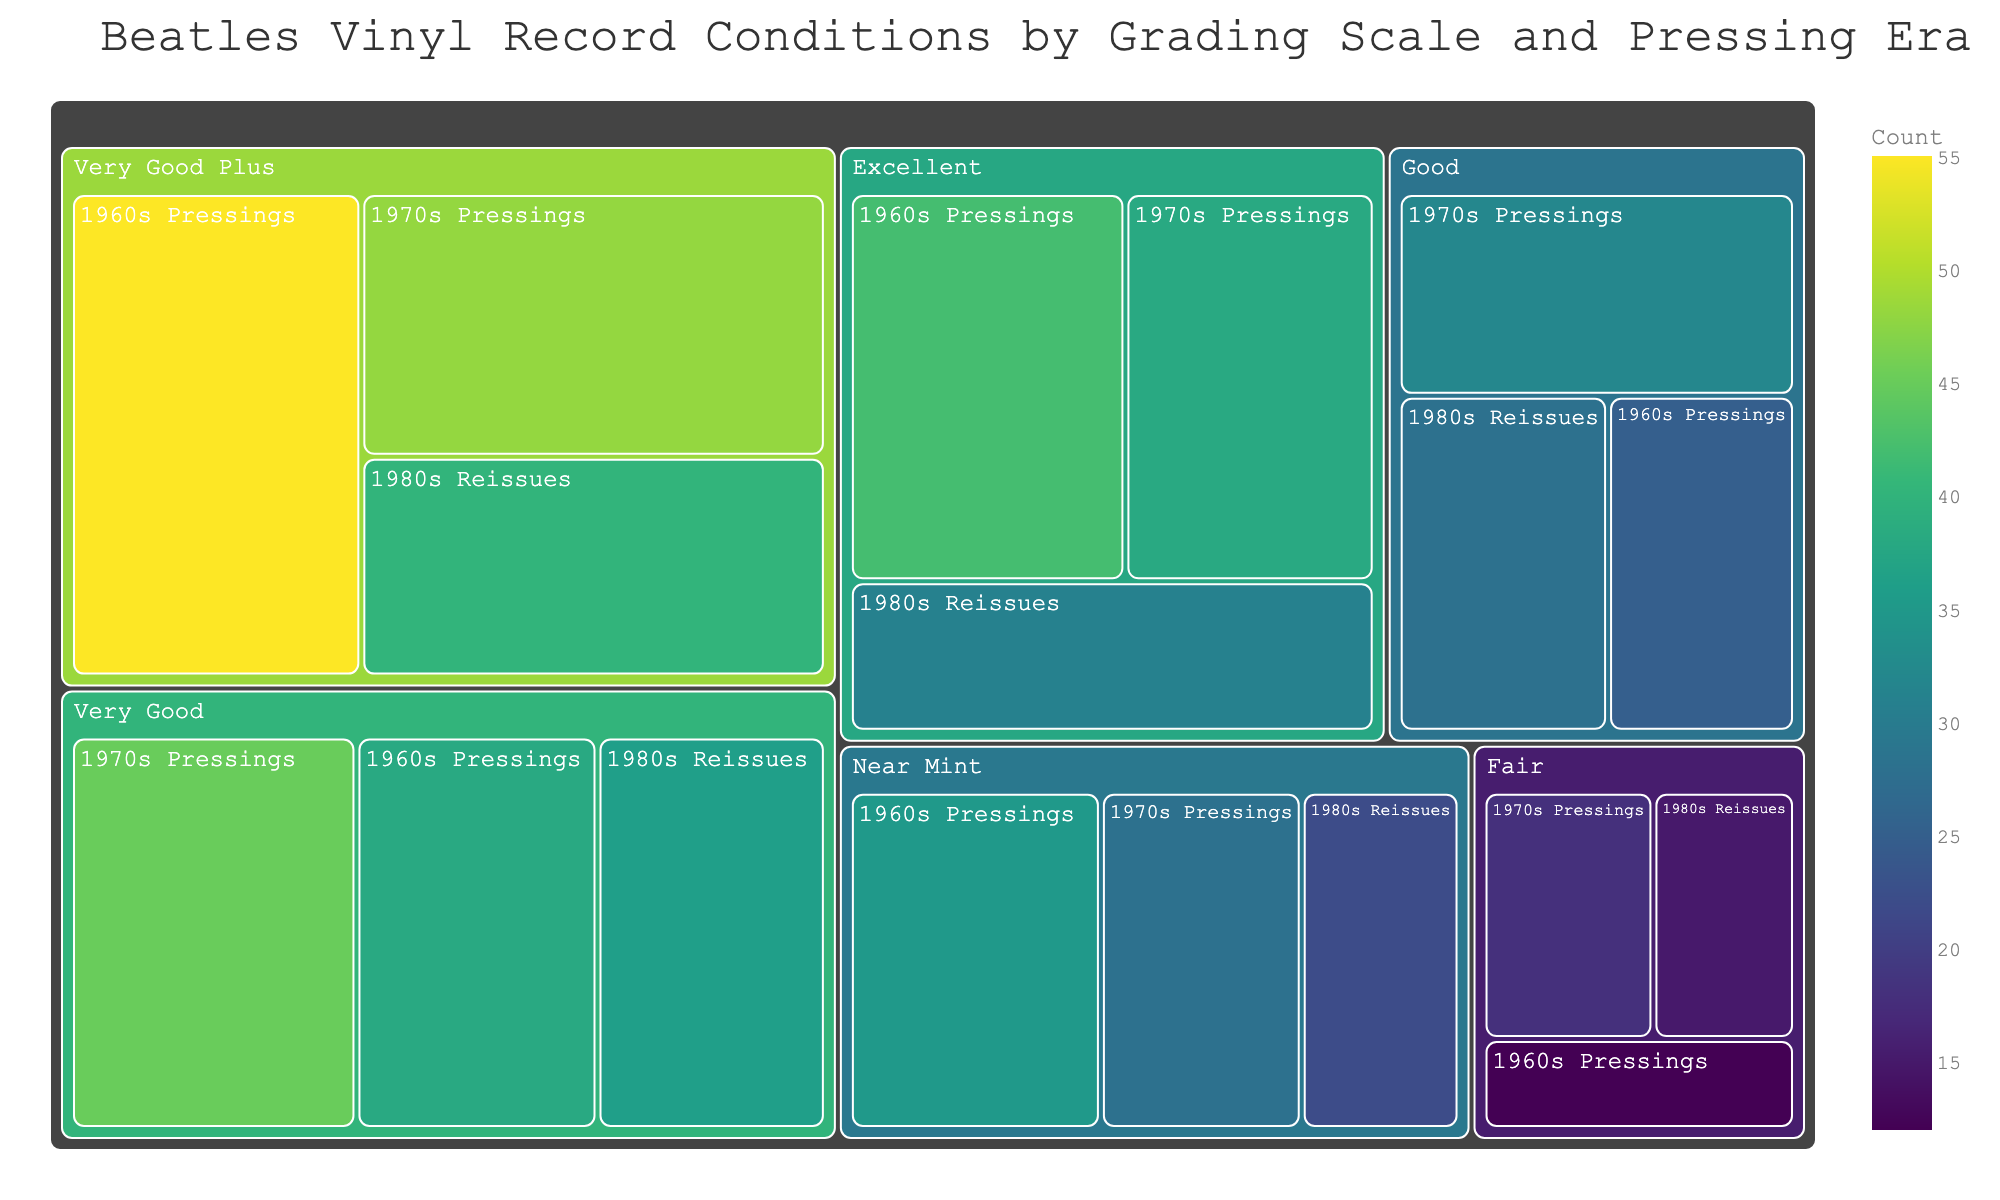what is the title of the Treemap? The title is displayed at the top of the figure. It reads, "Beatles Vinyl Record Conditions by Grading Scale and Pressing Era."
Answer: Beatles Vinyl Record Conditions by Grading Scale and Pressing Era Which grading scale category has the most records? By observing the size and depth of the boxes in the treemap, we can see that the "Very Good Plus" category has the largest total value.
Answer: Very Good Plus How many records are classified as "Near Mint" from the 1980s Reissues? Locate the "Near Mint" category and then find the subcategory "1980s Reissues." The value displayed in that box is 22.
Answer: 22 Which pressing era has the highest number of "Excellent" condition records? To find this, look at the "Excellent" category and compare the values across the subcategories. The "1960s Pressings" has the highest value with 42 records.
Answer: 1960s Pressings What is the combined total of "Good" condition records for all pressing eras? Find the values for "Good" condition in each subcategory and sum them up: 25 (1960s) + 32 (1970s) + 28 (1980s) = 85.
Answer: 85 Which subcategory under "Fair" condition has the least number of records? Under the "Fair" condition category, compare the three subcategories. The "1960s Pressings" has the lowest value with 12 records.
Answer: 1960s Pressings How do the number of "Very Good" condition records from the 1960s compare to the 1970s? Locate "Very Good" condition from both 1960s and 1970s and compare their values. The 1960s have 38 records, while the 1970s have 45. The 1970s have more records.
Answer: 1970s have more What is the difference in the number of "Excellent" and "Near Mint" condition records for 1970s Pressings? Find the values for both "Excellent" and "Near Mint" under 1970s Pressings. Excellent has 38 and Near Mint has 28. The difference is 38 - 28 = 10.
Answer: 10 What are the three categories with the highest total number of records? Sum the values for each category across all pressing eras and compare the sums. The three categories with the highest totals are "Very Good Plus," "Excellent," and "Very Good."
Answer: Very Good Plus, Excellent, Very Good Which pressing era has the overall highest number of records in all conditions combined? Sum all the values for each pressing era across all categories. The values are: 1960s (207), 1970s (237), 1980s (200). Therefore, the 1970s Pressings have the highest total.
Answer: 1970s Pressings 